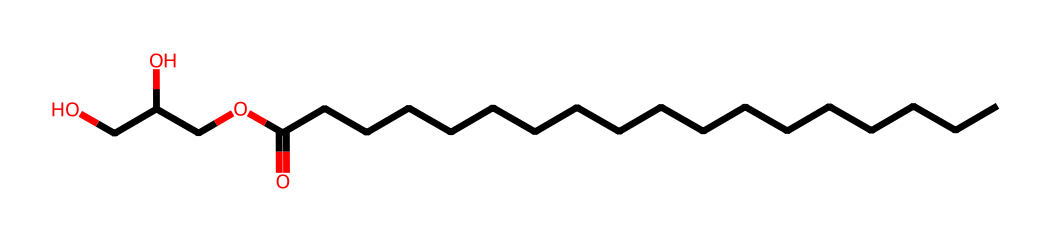How many carbon atoms are in glycerol monostearate? The SMILES representation indicates there are 18 carbon atoms (CCCCCCCCCCCCCCCCCC represents 18 C's in a chain and one more C in the glycerol part).
Answer: 18 What type of functional group is present at the end of the fatty acid chain? The presence of the carbonyl (C=O) and hydroxyl (O-H) groups at the end of the chain indicates a carboxylic acid functional group.
Answer: carboxylic acid How many oxygen atoms are in glycerol monostearate? Counting the oxygen atoms in the structure, there are four: one in the carbonyl group, two in the glycerol part, and one in the ester link.
Answer: 4 What type of bond connects the glycerol and fatty acid portions in glycerol monostearate? The bond connecting the glycerol moiety to the fatty acid is an ester bond (indicated by the -O- linkage in the structure).
Answer: ester bond What role does glycerol monostearate play as a surfactant? Glycerol monostearate acts as an emulsifier, reducing surface tension between water and oil phases in mixtures.
Answer: emulsifier What is the molecular formula of glycerol monostearate from its structure? By analyzing the molecular structure, the molecular formula can be calculated as C21H42O4, reflecting the total count of carbon, hydrogen, and oxygen atoms.
Answer: C21H42O4 